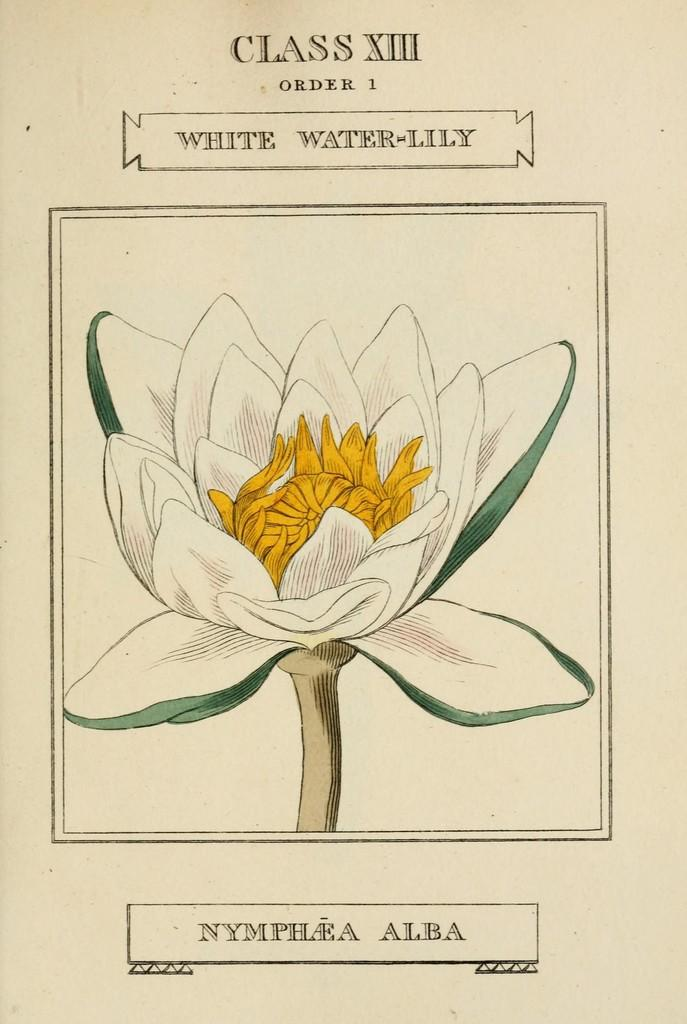What is the main subject of the painting in the image? The main subject of the painting in the image is a flower. What else is present in the image besides the painting? There is text on a white paper in the image. What type of feeling does the kettle have in the image? There is no kettle present in the image, so it is not possible to determine any feelings it might have. 